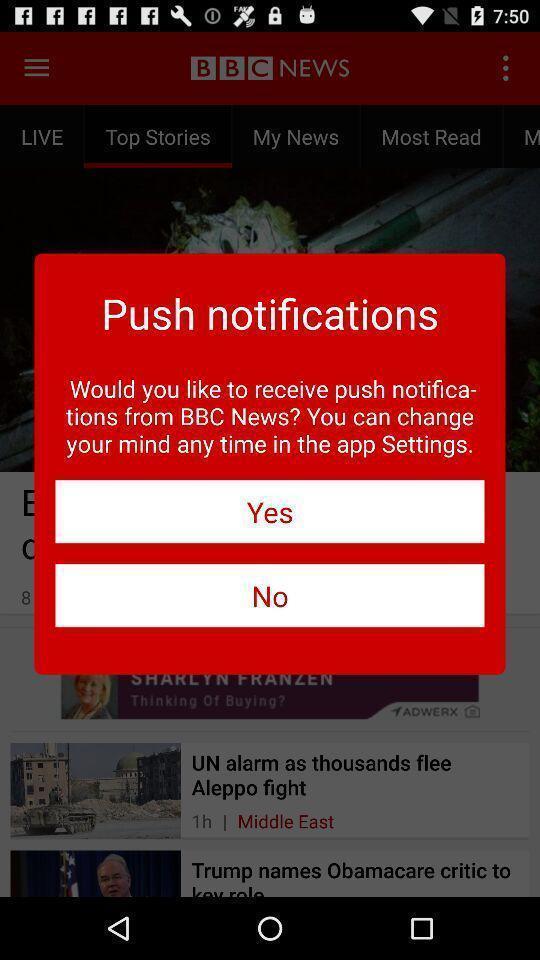Describe the visual elements of this screenshot. Pop-up to receive notifications about the app. 